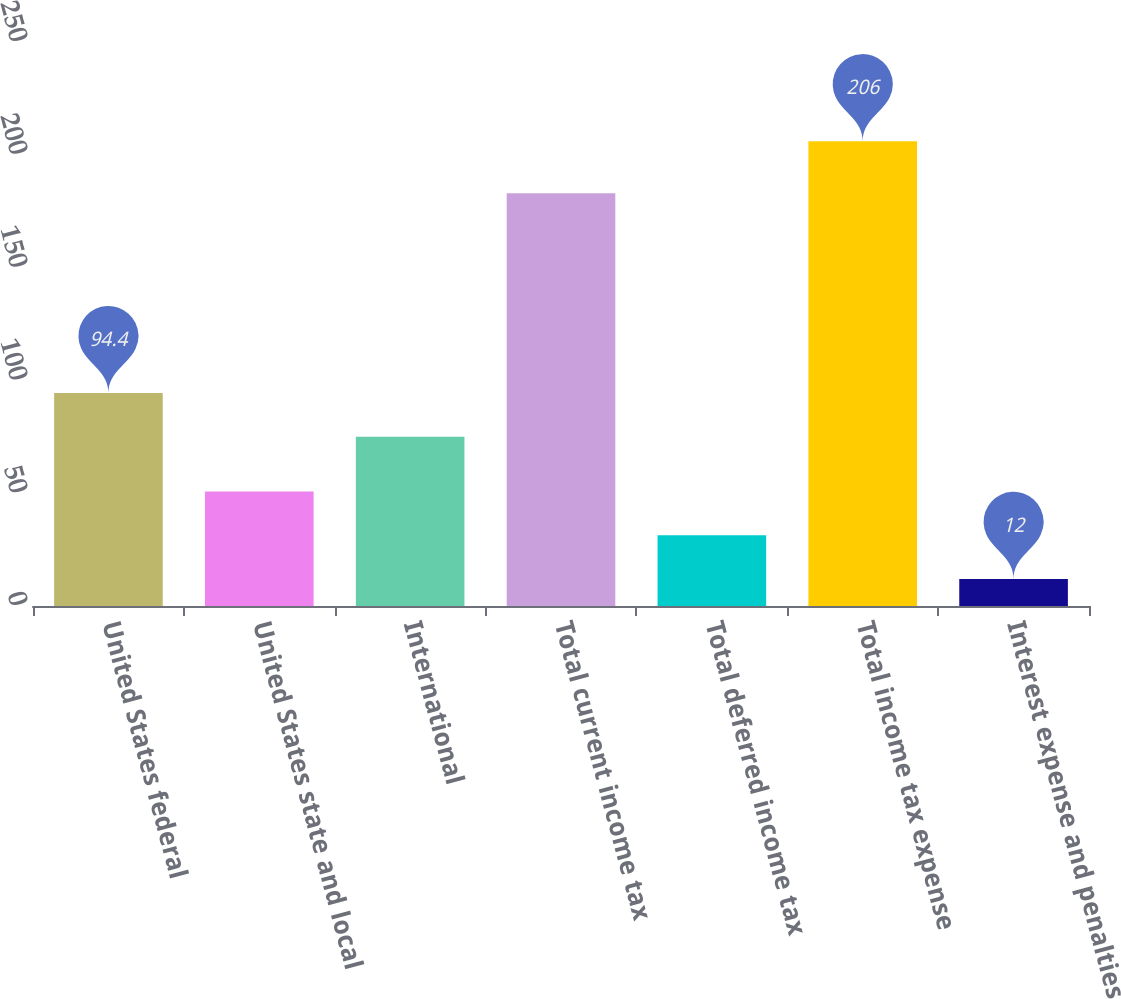Convert chart. <chart><loc_0><loc_0><loc_500><loc_500><bar_chart><fcel>United States federal<fcel>United States state and local<fcel>International<fcel>Total current income tax<fcel>Total deferred income tax<fcel>Total income tax expense<fcel>Interest expense and penalties<nl><fcel>94.4<fcel>50.8<fcel>75<fcel>183<fcel>31.4<fcel>206<fcel>12<nl></chart> 